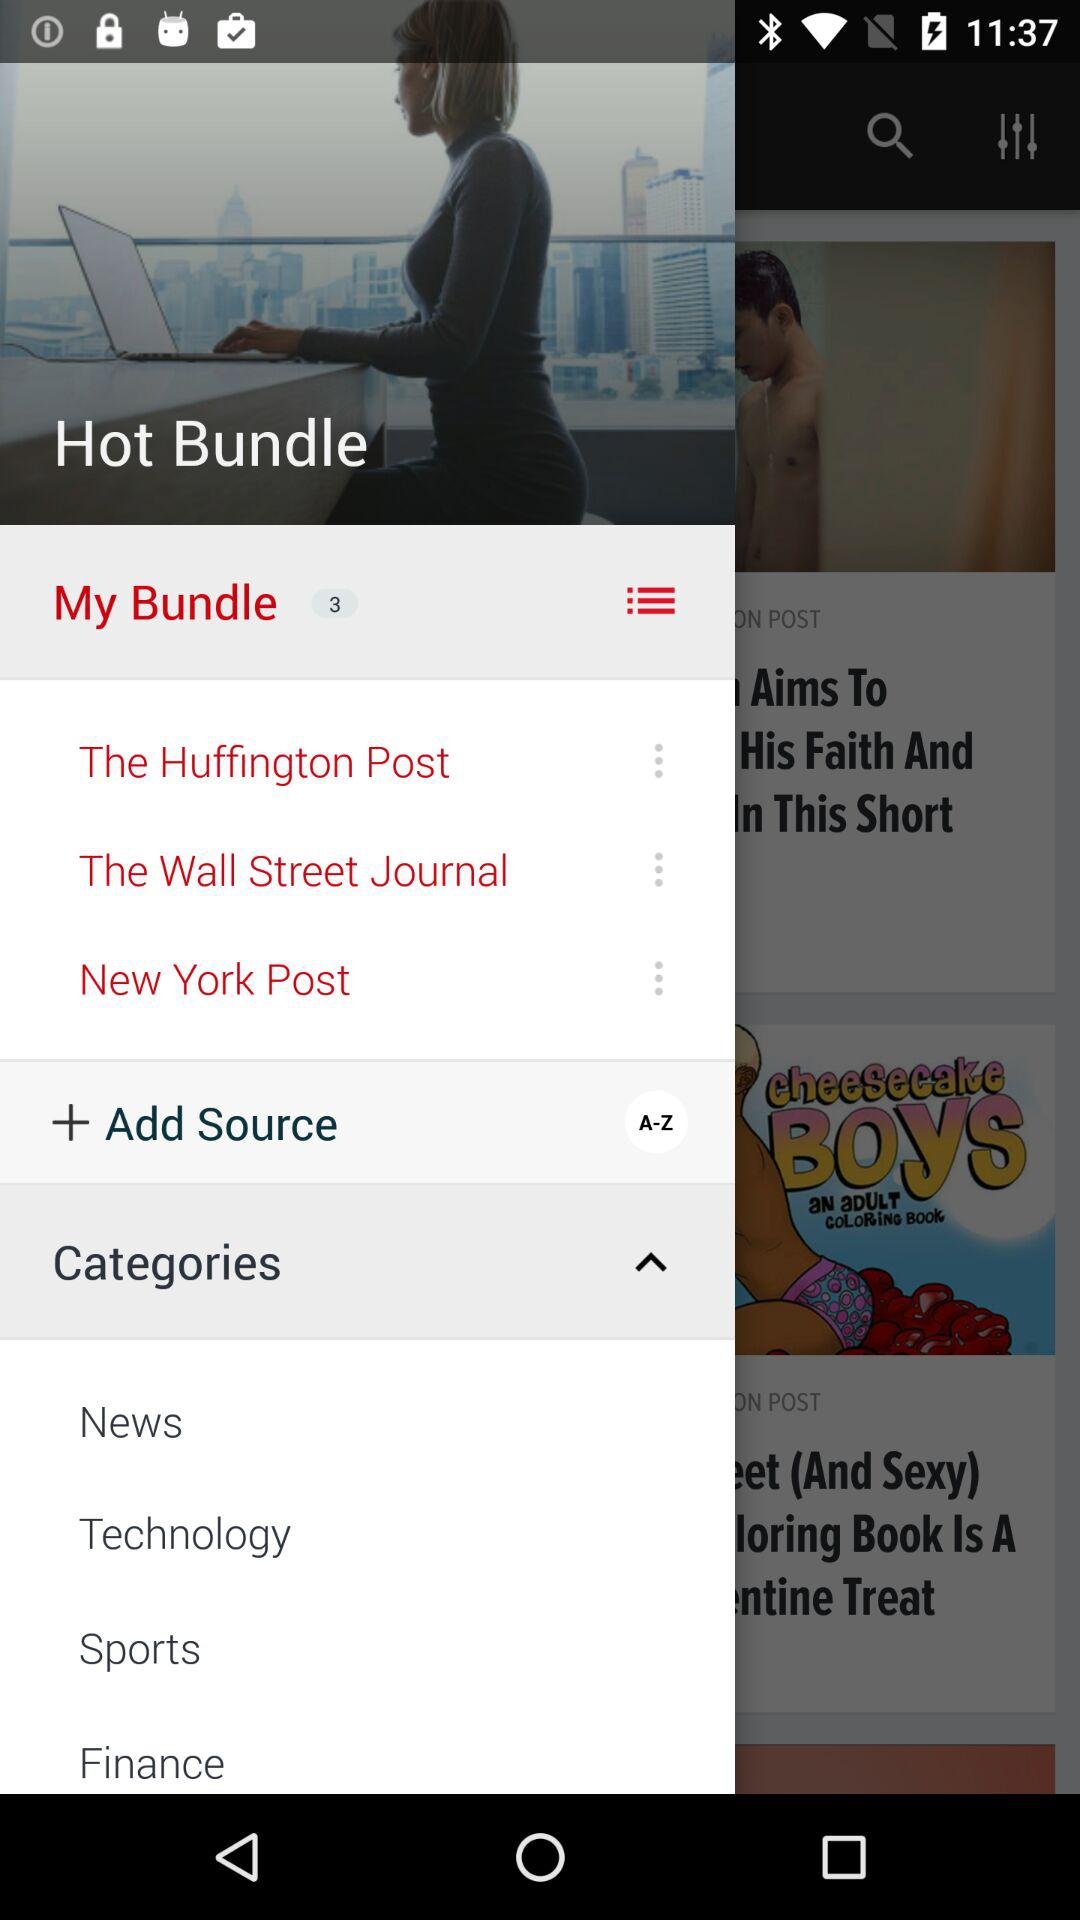What is the username?
When the provided information is insufficient, respond with <no answer>. <no answer> 